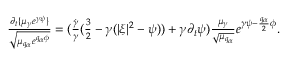<formula> <loc_0><loc_0><loc_500><loc_500>\begin{array} { r } { \frac { \partial _ { t } \{ \mu _ { \gamma } e ^ { \gamma \psi } \} } { \sqrt { \mu _ { q _ { \alpha } } e ^ { q _ { \alpha } \phi } } } = ( \frac { \dot { \gamma } } { \gamma } ( \frac { 3 } { 2 } - \gamma ( | \xi | ^ { 2 } - \psi ) ) + \gamma \partial _ { t } \psi ) \frac { \mu _ { \gamma } } { \sqrt { \mu _ { q _ { \alpha } } } } e ^ { \gamma \psi - \frac { q _ { \alpha } } { 2 } \phi } . } \end{array}</formula> 